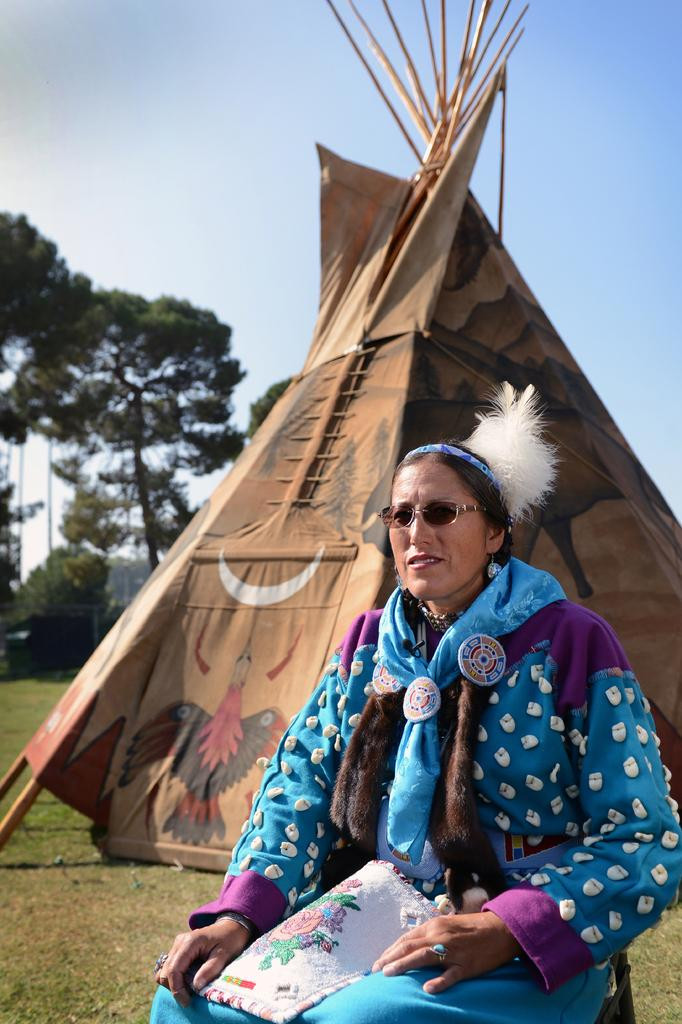Who is present in the image? There is a woman in the image. What is the woman doing in the image? The woman is sitting in front of a tent. What is the woman wearing in the image? The woman is wearing a blue dress and goggles. What can be seen behind the tent in the image? There are trees behind the tent. What type of corn is being used as a pillow in the image? There is no corn present in the image, and it is not being used as a pillow. 